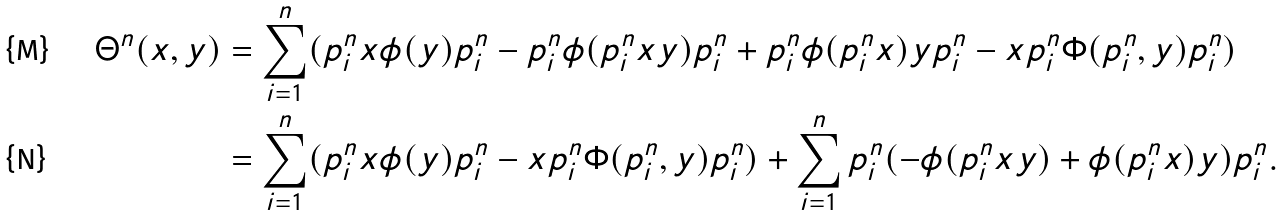<formula> <loc_0><loc_0><loc_500><loc_500>\Theta ^ { n } ( x , y ) & = \sum _ { i = 1 } ^ { n } ( p ^ { n } _ { i } x \phi ( y ) p ^ { n } _ { i } - p ^ { n } _ { i } \phi ( p ^ { n } _ { i } x y ) p ^ { n } _ { i } + p ^ { n } _ { i } \phi ( p ^ { n } _ { i } x ) y p ^ { n } _ { i } - x p ^ { n } _ { i } \Phi ( p ^ { n } _ { i } , y ) p ^ { n } _ { i } ) \\ & = \sum _ { i = 1 } ^ { n } ( p ^ { n } _ { i } x \phi ( y ) p ^ { n } _ { i } - x p ^ { n } _ { i } \Phi ( p ^ { n } _ { i } , y ) p ^ { n } _ { i } ) + \sum _ { i = 1 } ^ { n } p ^ { n } _ { i } ( - \phi ( p ^ { n } _ { i } x y ) + \phi ( p ^ { n } _ { i } x ) y ) p ^ { n } _ { i } .</formula> 